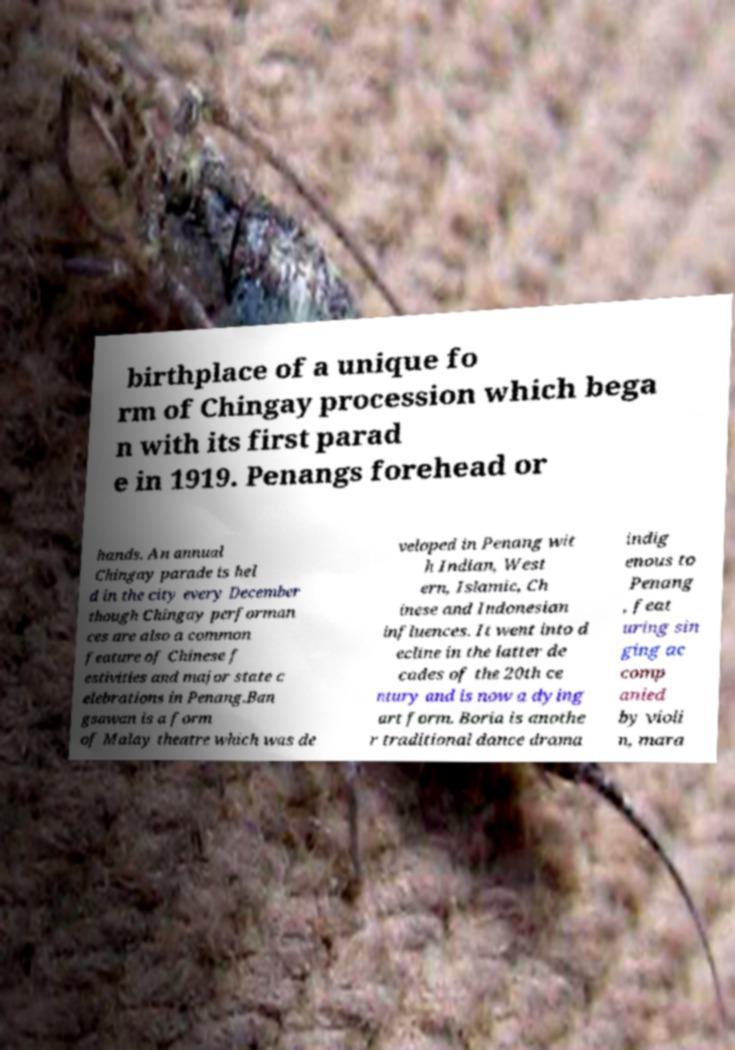Can you accurately transcribe the text from the provided image for me? birthplace of a unique fo rm of Chingay procession which bega n with its first parad e in 1919. Penangs forehead or hands. An annual Chingay parade is hel d in the city every December though Chingay performan ces are also a common feature of Chinese f estivities and major state c elebrations in Penang.Ban gsawan is a form of Malay theatre which was de veloped in Penang wit h Indian, West ern, Islamic, Ch inese and Indonesian influences. It went into d ecline in the latter de cades of the 20th ce ntury and is now a dying art form. Boria is anothe r traditional dance drama indig enous to Penang , feat uring sin ging ac comp anied by violi n, mara 